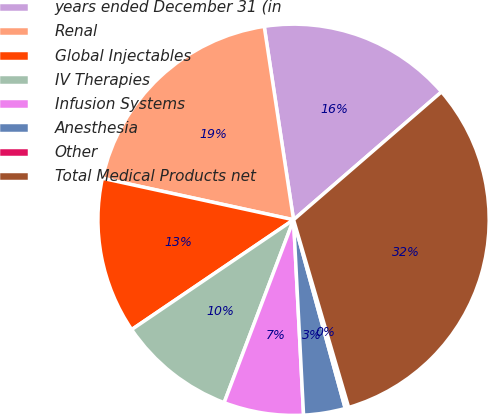Convert chart to OTSL. <chart><loc_0><loc_0><loc_500><loc_500><pie_chart><fcel>years ended December 31 (in<fcel>Renal<fcel>Global Injectables<fcel>IV Therapies<fcel>Infusion Systems<fcel>Anesthesia<fcel>Other<fcel>Total Medical Products net<nl><fcel>16.05%<fcel>19.2%<fcel>12.89%<fcel>9.74%<fcel>6.59%<fcel>3.44%<fcel>0.29%<fcel>31.8%<nl></chart> 